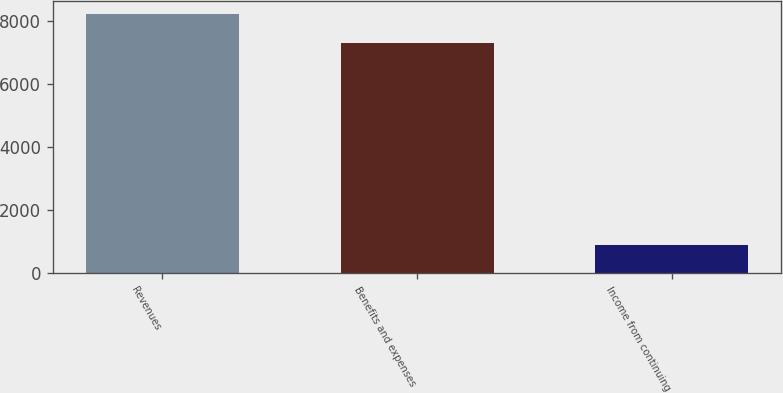Convert chart. <chart><loc_0><loc_0><loc_500><loc_500><bar_chart><fcel>Revenues<fcel>Benefits and expenses<fcel>Income from continuing<nl><fcel>8231<fcel>7316<fcel>915<nl></chart> 